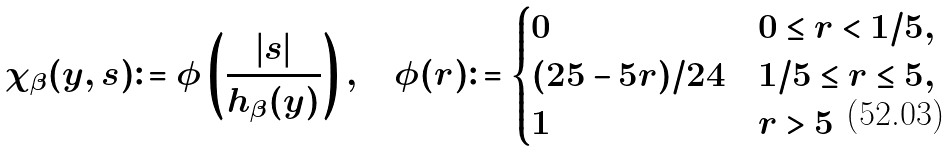<formula> <loc_0><loc_0><loc_500><loc_500>\chi _ { \beta } ( y , s ) \colon = \phi \left ( \frac { | s | } { h _ { \beta } ( y ) } \right ) , \quad \phi ( r ) & \colon = \begin{cases} 0 & 0 \leq r < 1 / 5 , \\ ( 2 5 - 5 r ) / 2 4 & 1 / 5 \leq r \leq 5 , \\ 1 & r > 5 \end{cases}</formula> 